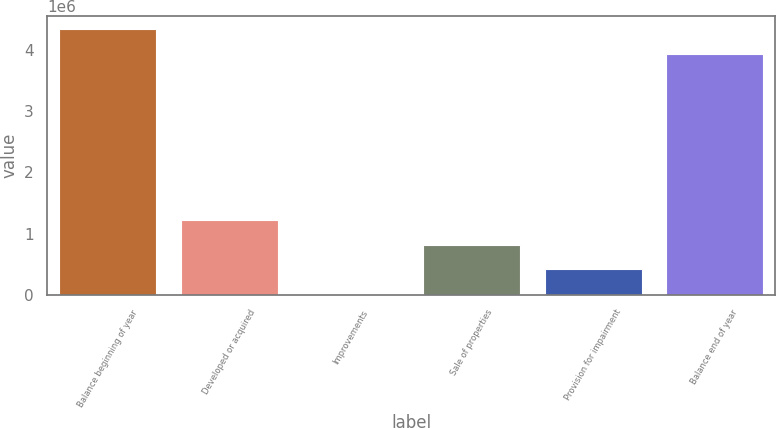<chart> <loc_0><loc_0><loc_500><loc_500><bar_chart><fcel>Balance beginning of year<fcel>Developed or acquired<fcel>Improvements<fcel>Sale of properties<fcel>Provision for impairment<fcel>Balance end of year<nl><fcel>4.33646e+06<fcel>1.22368e+06<fcel>15617<fcel>820991<fcel>418304<fcel>3.93378e+06<nl></chart> 